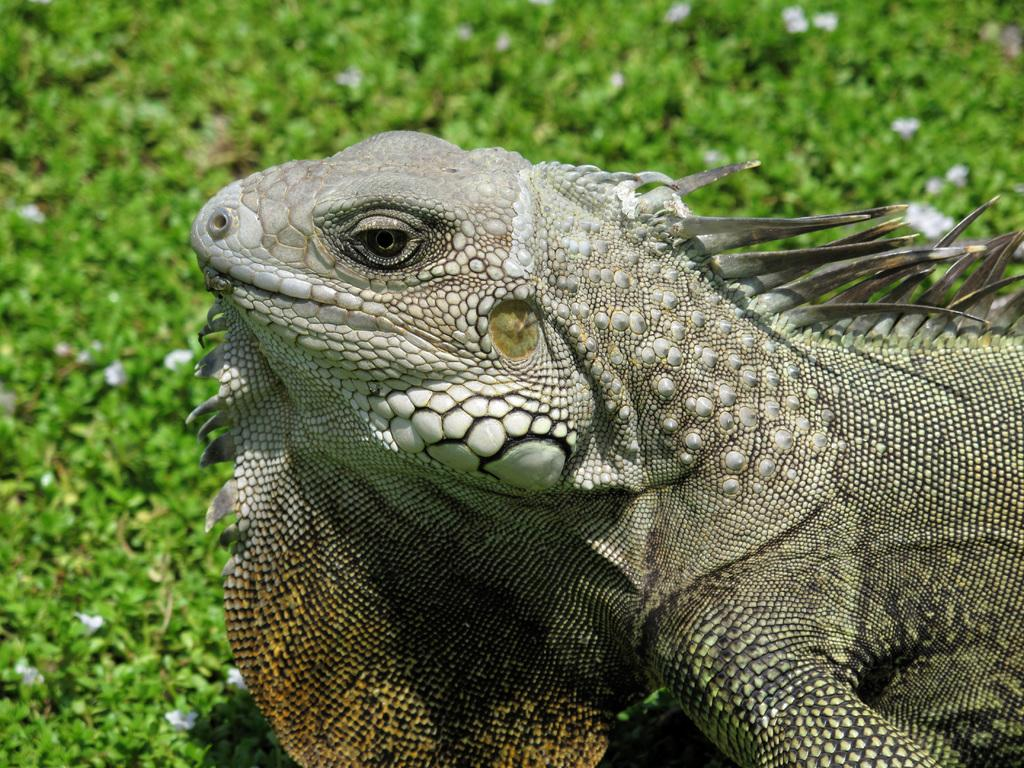What type of animal is in the picture? There is a reptile in the picture. What can be seen at the bottom of the picture? There are plants at the bottom of the picture. What color are the flowers in the picture? There are white color flowers in the picture. What type of paint is used to color the reptile's stomach in the picture? There is no paint or mention of the reptile's stomach in the picture; it is a photograph of a real reptile. 